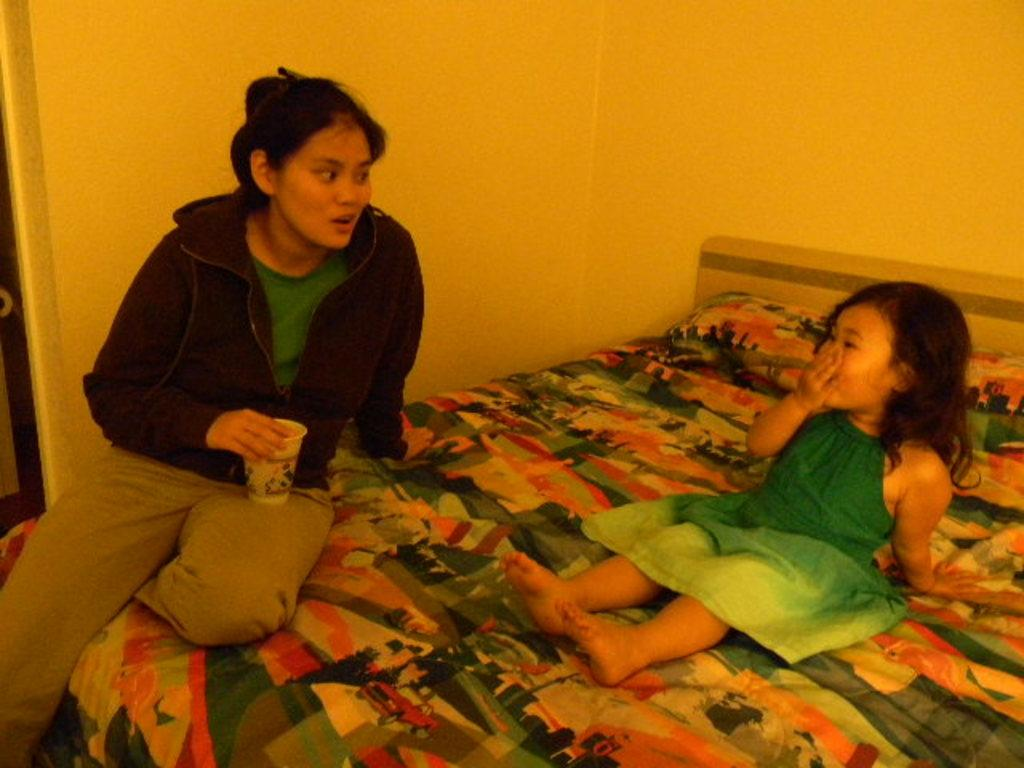What is the girl doing in the image? The girl is sitting on a bed in the image. Who is with the girl in the image? There is a woman sitting and looking at the girl in the image. What can be seen behind the girl and woman in the image? There is a wall visible in the image. How many cats are playing with a string in the image? There are no cats or strings present in the image. Who is the friend of the girl in the image? The provided facts do not mention a friend of the girl in the image. 